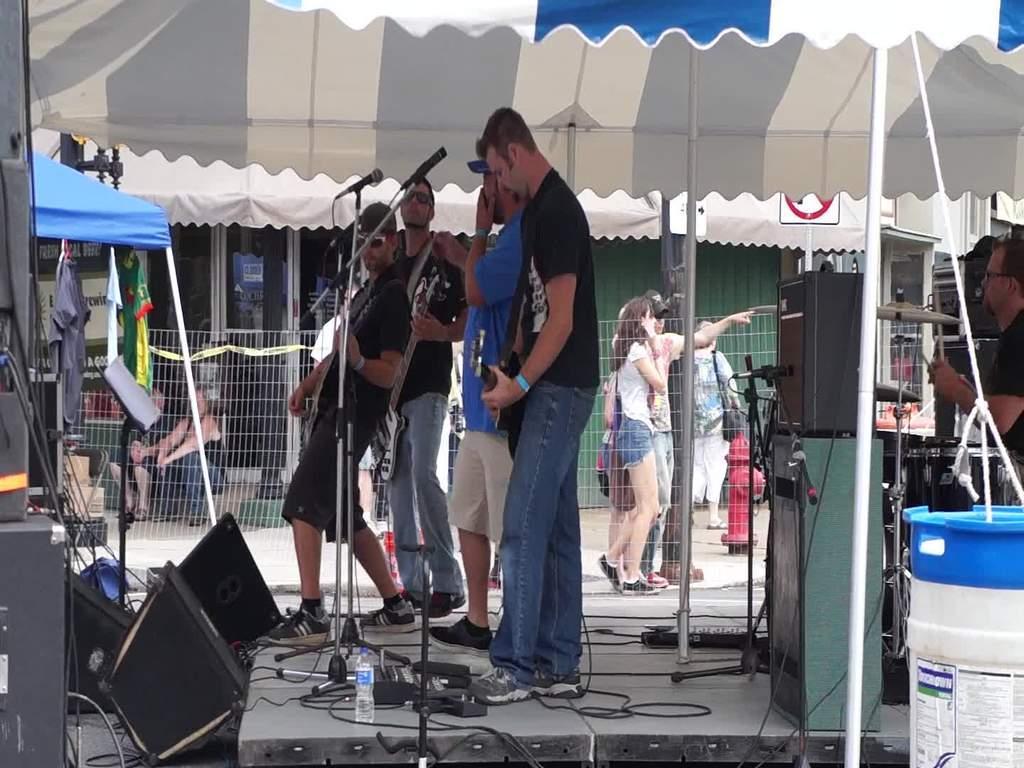Describe this image in one or two sentences. In this image we can see few people, some of them are standing on the stage and playing musical instruments, there are speakers, a bottle, mics and few other objects on the stage and there is a tent, a fire hydrant, fence and building in the background. 